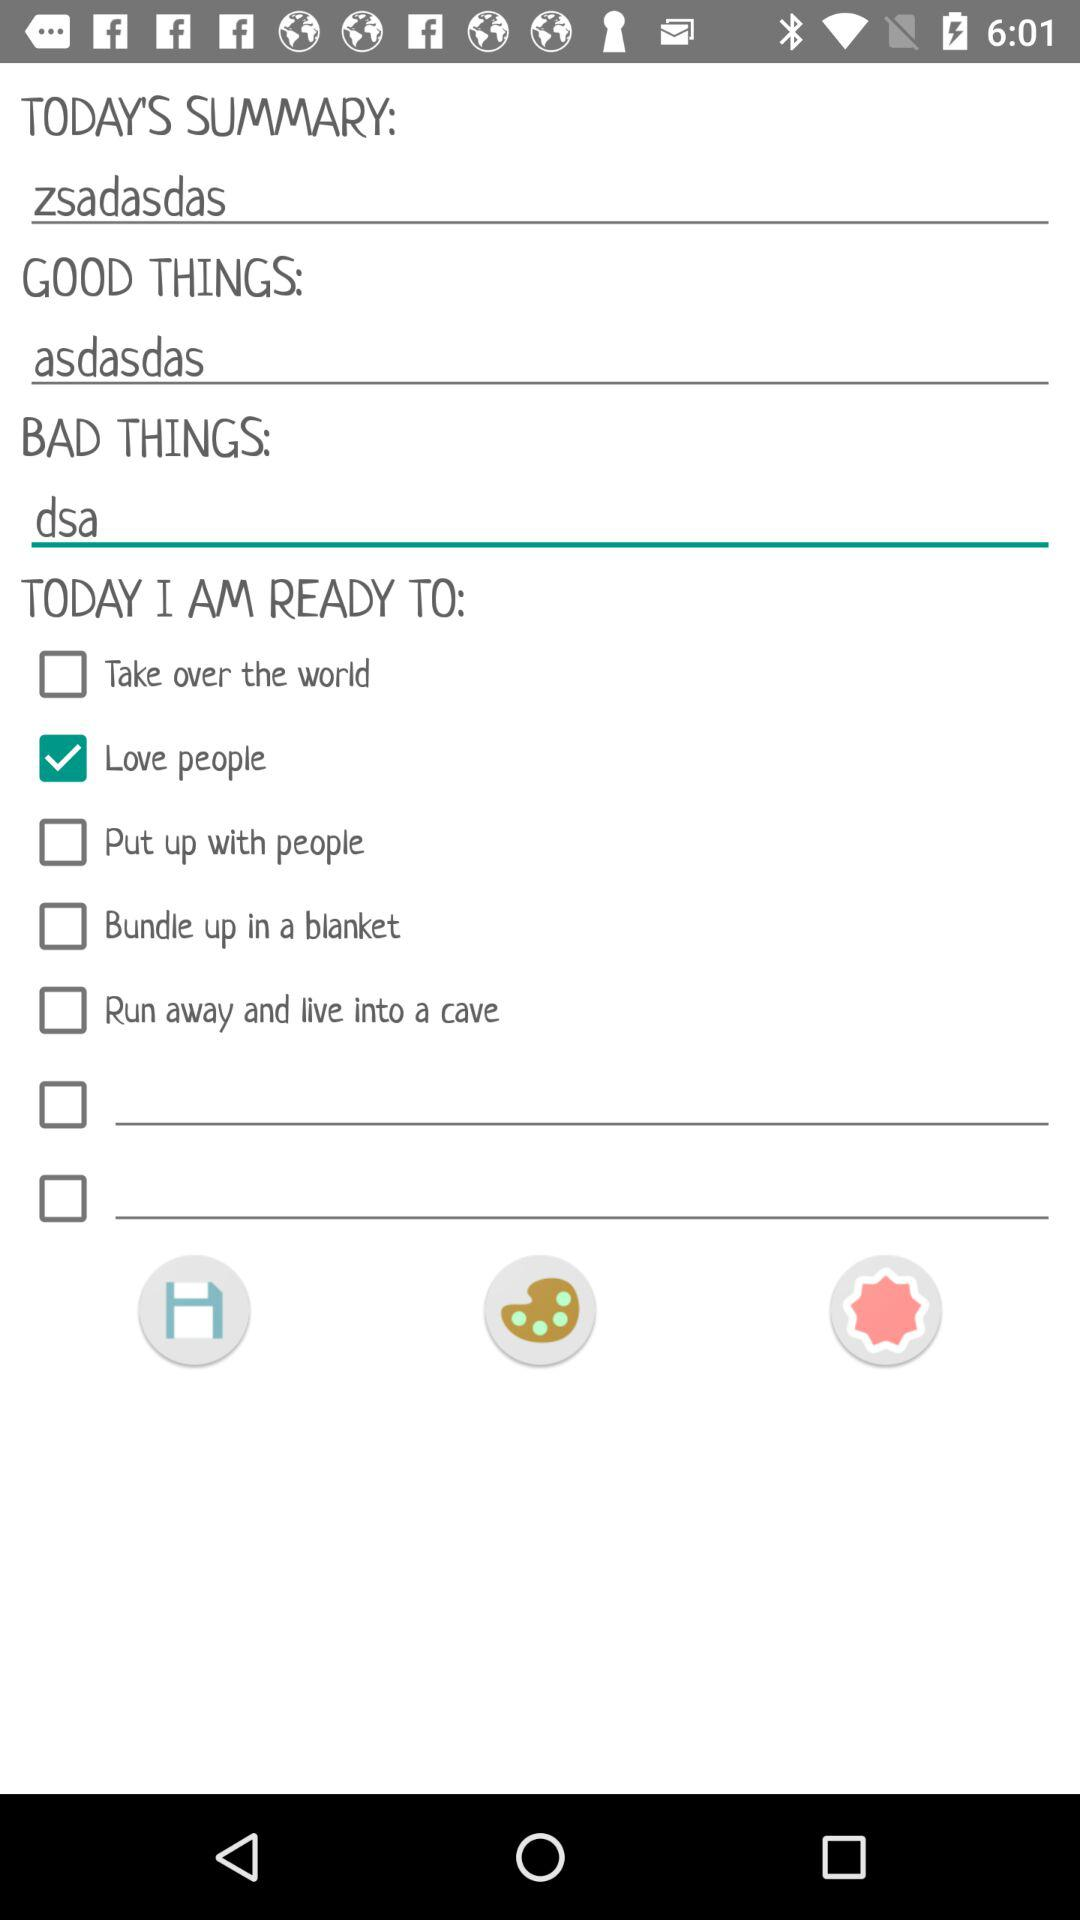What is the status of "Love people"? The status of "Love people" is "on". 